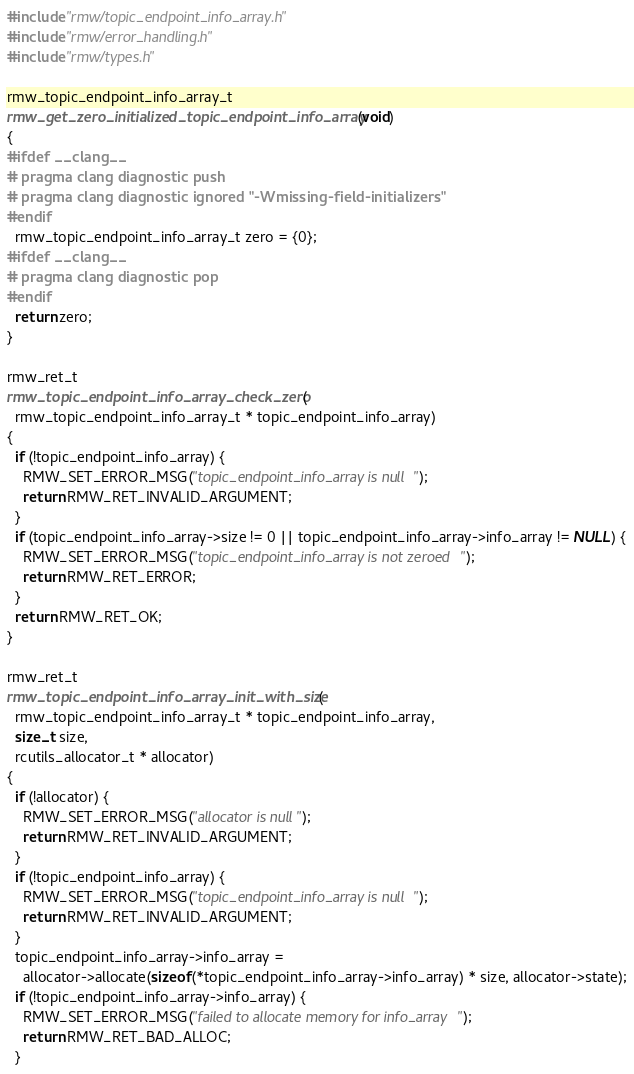<code> <loc_0><loc_0><loc_500><loc_500><_C_>#include "rmw/topic_endpoint_info_array.h"
#include "rmw/error_handling.h"
#include "rmw/types.h"

rmw_topic_endpoint_info_array_t
rmw_get_zero_initialized_topic_endpoint_info_array(void)
{
#ifdef __clang__
# pragma clang diagnostic push
# pragma clang diagnostic ignored "-Wmissing-field-initializers"
#endif
  rmw_topic_endpoint_info_array_t zero = {0};
#ifdef __clang__
# pragma clang diagnostic pop
#endif
  return zero;
}

rmw_ret_t
rmw_topic_endpoint_info_array_check_zero(
  rmw_topic_endpoint_info_array_t * topic_endpoint_info_array)
{
  if (!topic_endpoint_info_array) {
    RMW_SET_ERROR_MSG("topic_endpoint_info_array is null");
    return RMW_RET_INVALID_ARGUMENT;
  }
  if (topic_endpoint_info_array->size != 0 || topic_endpoint_info_array->info_array != NULL) {
    RMW_SET_ERROR_MSG("topic_endpoint_info_array is not zeroed");
    return RMW_RET_ERROR;
  }
  return RMW_RET_OK;
}

rmw_ret_t
rmw_topic_endpoint_info_array_init_with_size(
  rmw_topic_endpoint_info_array_t * topic_endpoint_info_array,
  size_t size,
  rcutils_allocator_t * allocator)
{
  if (!allocator) {
    RMW_SET_ERROR_MSG("allocator is null");
    return RMW_RET_INVALID_ARGUMENT;
  }
  if (!topic_endpoint_info_array) {
    RMW_SET_ERROR_MSG("topic_endpoint_info_array is null");
    return RMW_RET_INVALID_ARGUMENT;
  }
  topic_endpoint_info_array->info_array =
    allocator->allocate(sizeof(*topic_endpoint_info_array->info_array) * size, allocator->state);
  if (!topic_endpoint_info_array->info_array) {
    RMW_SET_ERROR_MSG("failed to allocate memory for info_array");
    return RMW_RET_BAD_ALLOC;
  }</code> 